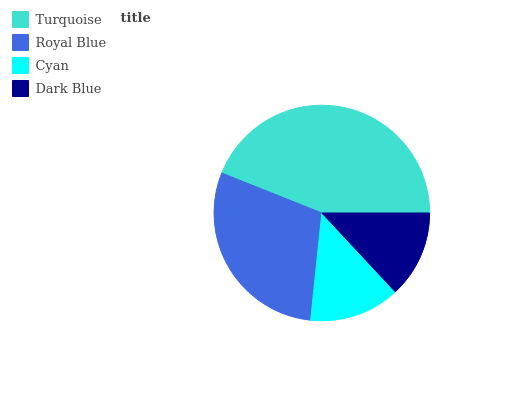Is Dark Blue the minimum?
Answer yes or no. Yes. Is Turquoise the maximum?
Answer yes or no. Yes. Is Royal Blue the minimum?
Answer yes or no. No. Is Royal Blue the maximum?
Answer yes or no. No. Is Turquoise greater than Royal Blue?
Answer yes or no. Yes. Is Royal Blue less than Turquoise?
Answer yes or no. Yes. Is Royal Blue greater than Turquoise?
Answer yes or no. No. Is Turquoise less than Royal Blue?
Answer yes or no. No. Is Royal Blue the high median?
Answer yes or no. Yes. Is Cyan the low median?
Answer yes or no. Yes. Is Dark Blue the high median?
Answer yes or no. No. Is Dark Blue the low median?
Answer yes or no. No. 